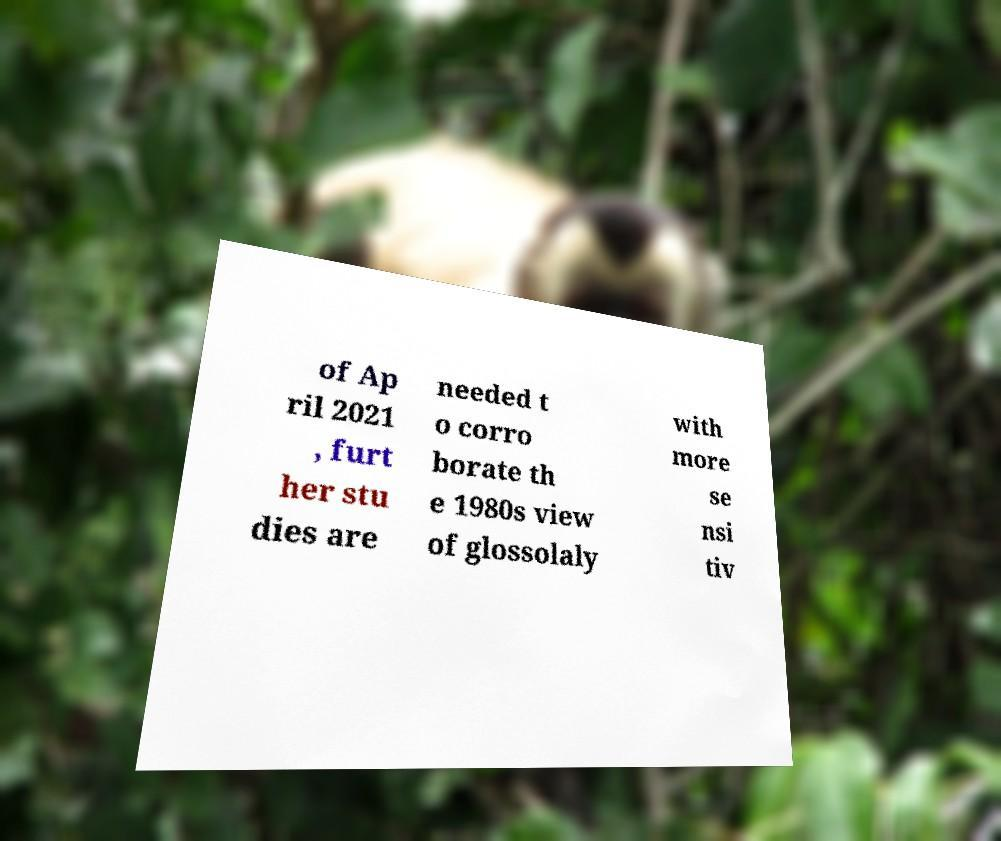I need the written content from this picture converted into text. Can you do that? of Ap ril 2021 , furt her stu dies are needed t o corro borate th e 1980s view of glossolaly with more se nsi tiv 